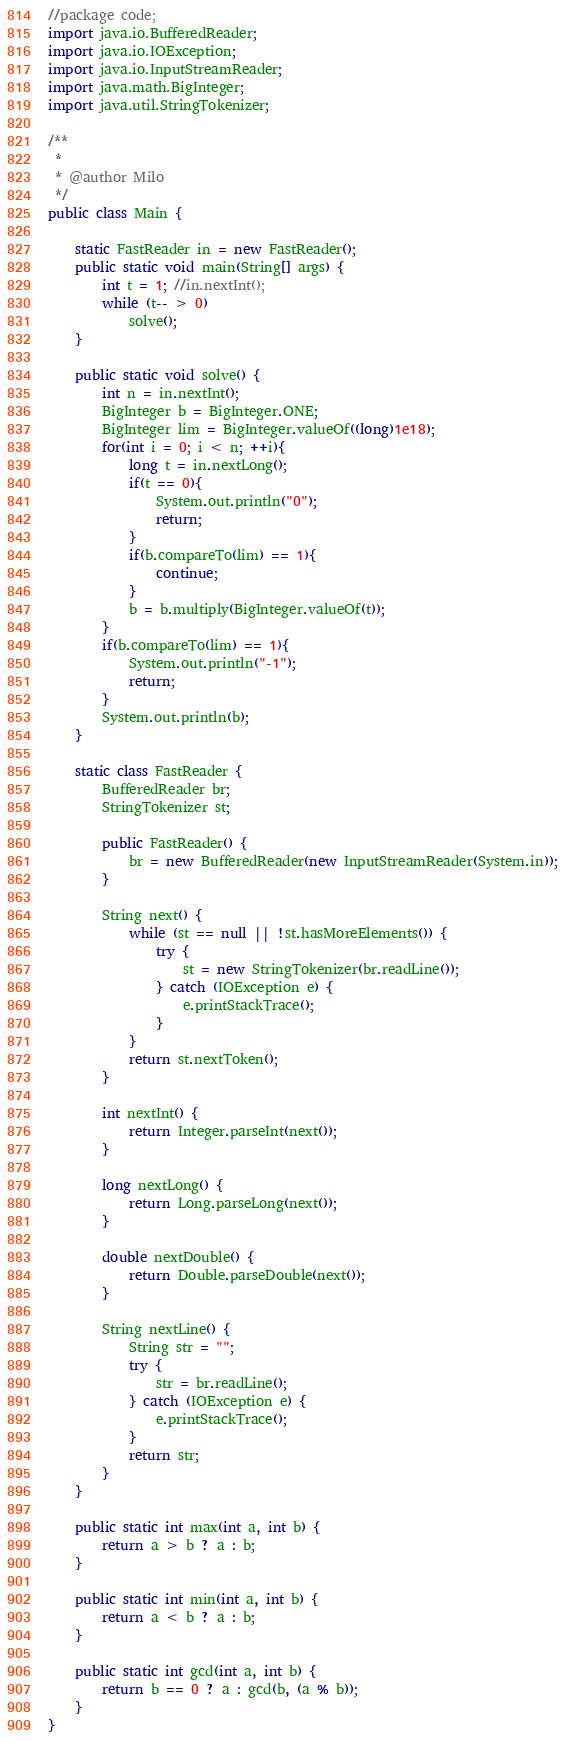Convert code to text. <code><loc_0><loc_0><loc_500><loc_500><_Java_>//package code;
import java.io.BufferedReader;
import java.io.IOException;
import java.io.InputStreamReader;
import java.math.BigInteger;
import java.util.StringTokenizer;

/**
 *
 * @author Milo
 */
public class Main {
    
    static FastReader in = new FastReader();
    public static void main(String[] args) {
        int t = 1; //in.nextInt();
        while (t-- > 0)
            solve();
    }
 
    public static void solve() {
        int n = in.nextInt();
        BigInteger b = BigInteger.ONE;
        BigInteger lim = BigInteger.valueOf((long)1e18);
        for(int i = 0; i < n; ++i){
            long t = in.nextLong();
            if(t == 0){
                System.out.println("0");
                return;
            }
            if(b.compareTo(lim) == 1){
                continue;
            }
            b = b.multiply(BigInteger.valueOf(t));
        }
        if(b.compareTo(lim) == 1){
            System.out.println("-1");
            return;
        }
        System.out.println(b);
    }

    static class FastReader {
        BufferedReader br;
        StringTokenizer st;
 
        public FastReader() {
            br = new BufferedReader(new InputStreamReader(System.in));
        }
 
        String next() {
            while (st == null || !st.hasMoreElements()) {
                try {
                    st = new StringTokenizer(br.readLine());
                } catch (IOException e) {
                    e.printStackTrace();
                }
            }
            return st.nextToken();
        }
 
        int nextInt() {
            return Integer.parseInt(next());
        }
 
        long nextLong() {
            return Long.parseLong(next());
        }
 
        double nextDouble() {
            return Double.parseDouble(next());
        }
 
        String nextLine() {
            String str = "";
            try {
                str = br.readLine();
            } catch (IOException e) {
                e.printStackTrace();
            }
            return str;
        }
    }
 
    public static int max(int a, int b) {
        return a > b ? a : b;
    }
 
    public static int min(int a, int b) {
        return a < b ? a : b;
    }
 
    public static int gcd(int a, int b) {
        return b == 0 ? a : gcd(b, (a % b));
    }
}
</code> 